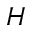Convert formula to latex. <formula><loc_0><loc_0><loc_500><loc_500>H</formula> 